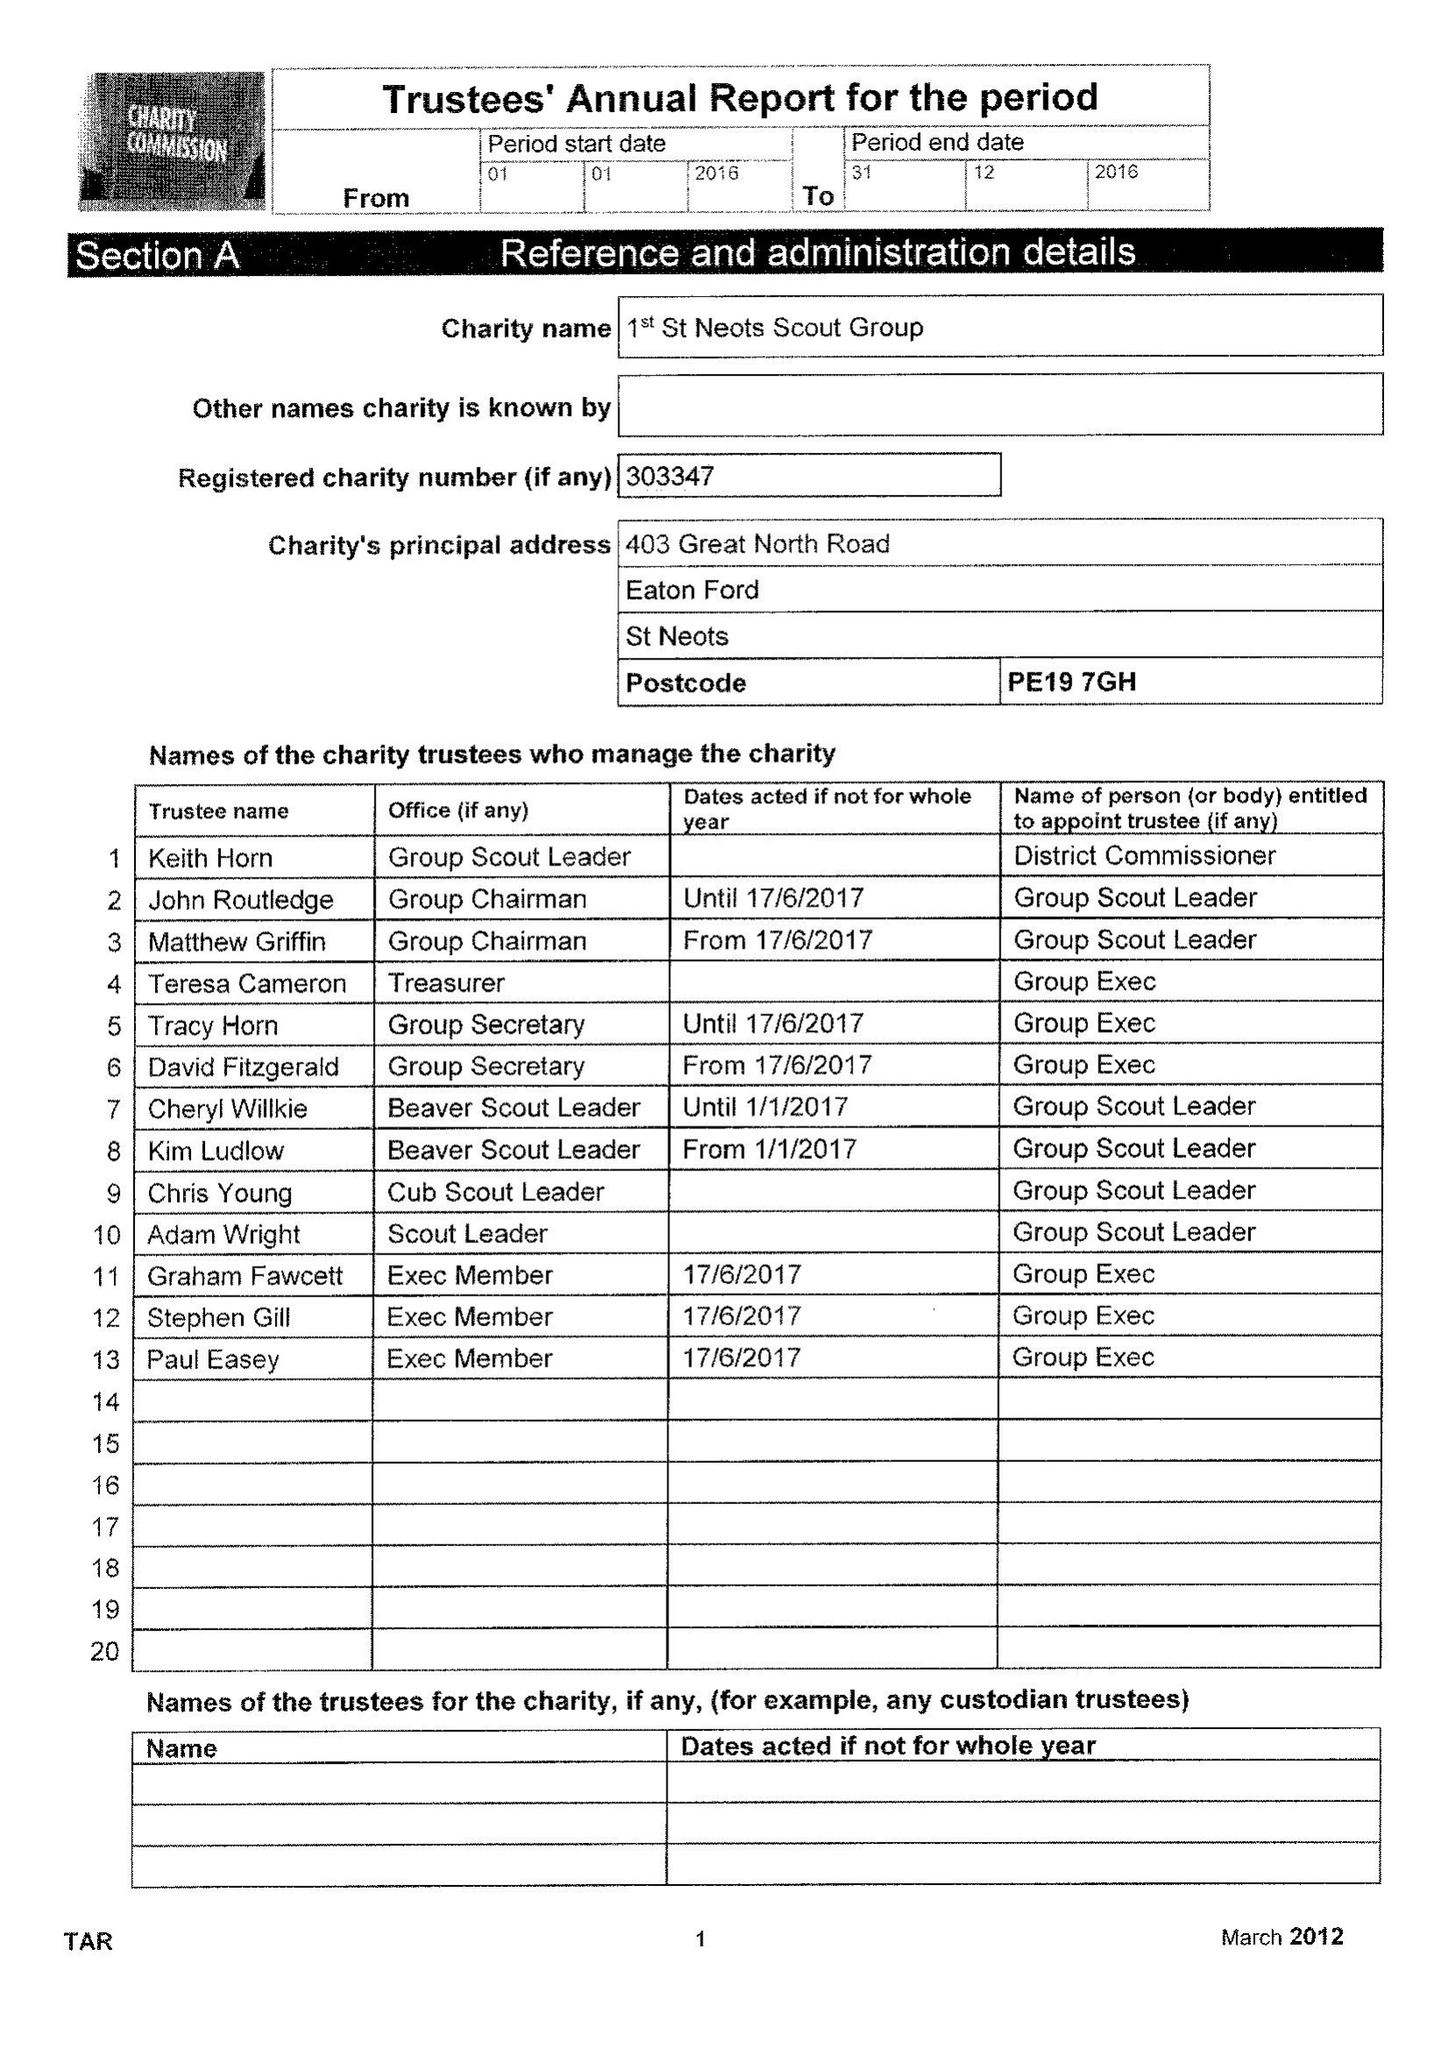What is the value for the address__post_town?
Answer the question using a single word or phrase. ST. NEOTS 